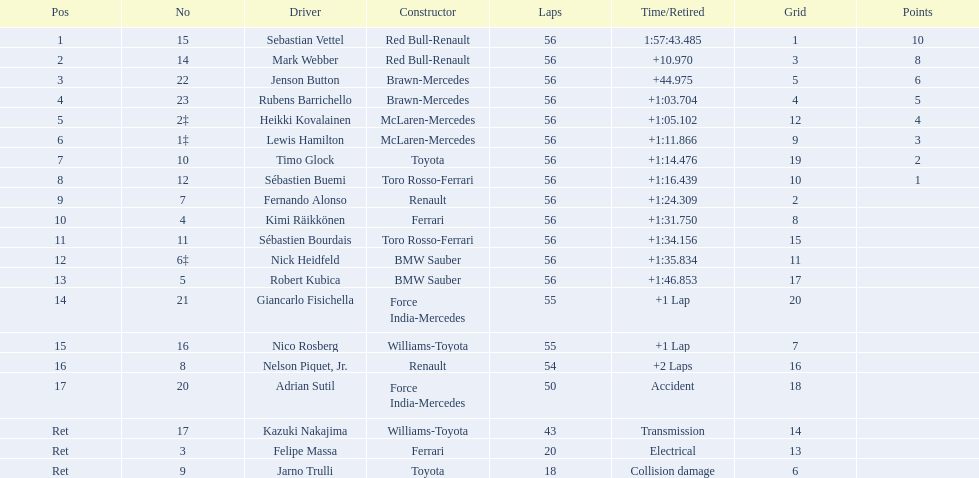Which driver stepped down because of electrical problems? Felipe Massa. Which driver withdrew due to an accident? Adrian Sutil. Which driver left due to collision damage? Jarno Trulli. 